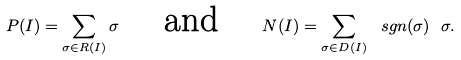Convert formula to latex. <formula><loc_0><loc_0><loc_500><loc_500>P ( I ) = \sum _ { \sigma \in R ( I ) } \sigma \quad \text { and } \quad N ( I ) = \sum _ { \sigma \in D ( I ) } \ s g n ( \sigma ) \ \sigma .</formula> 